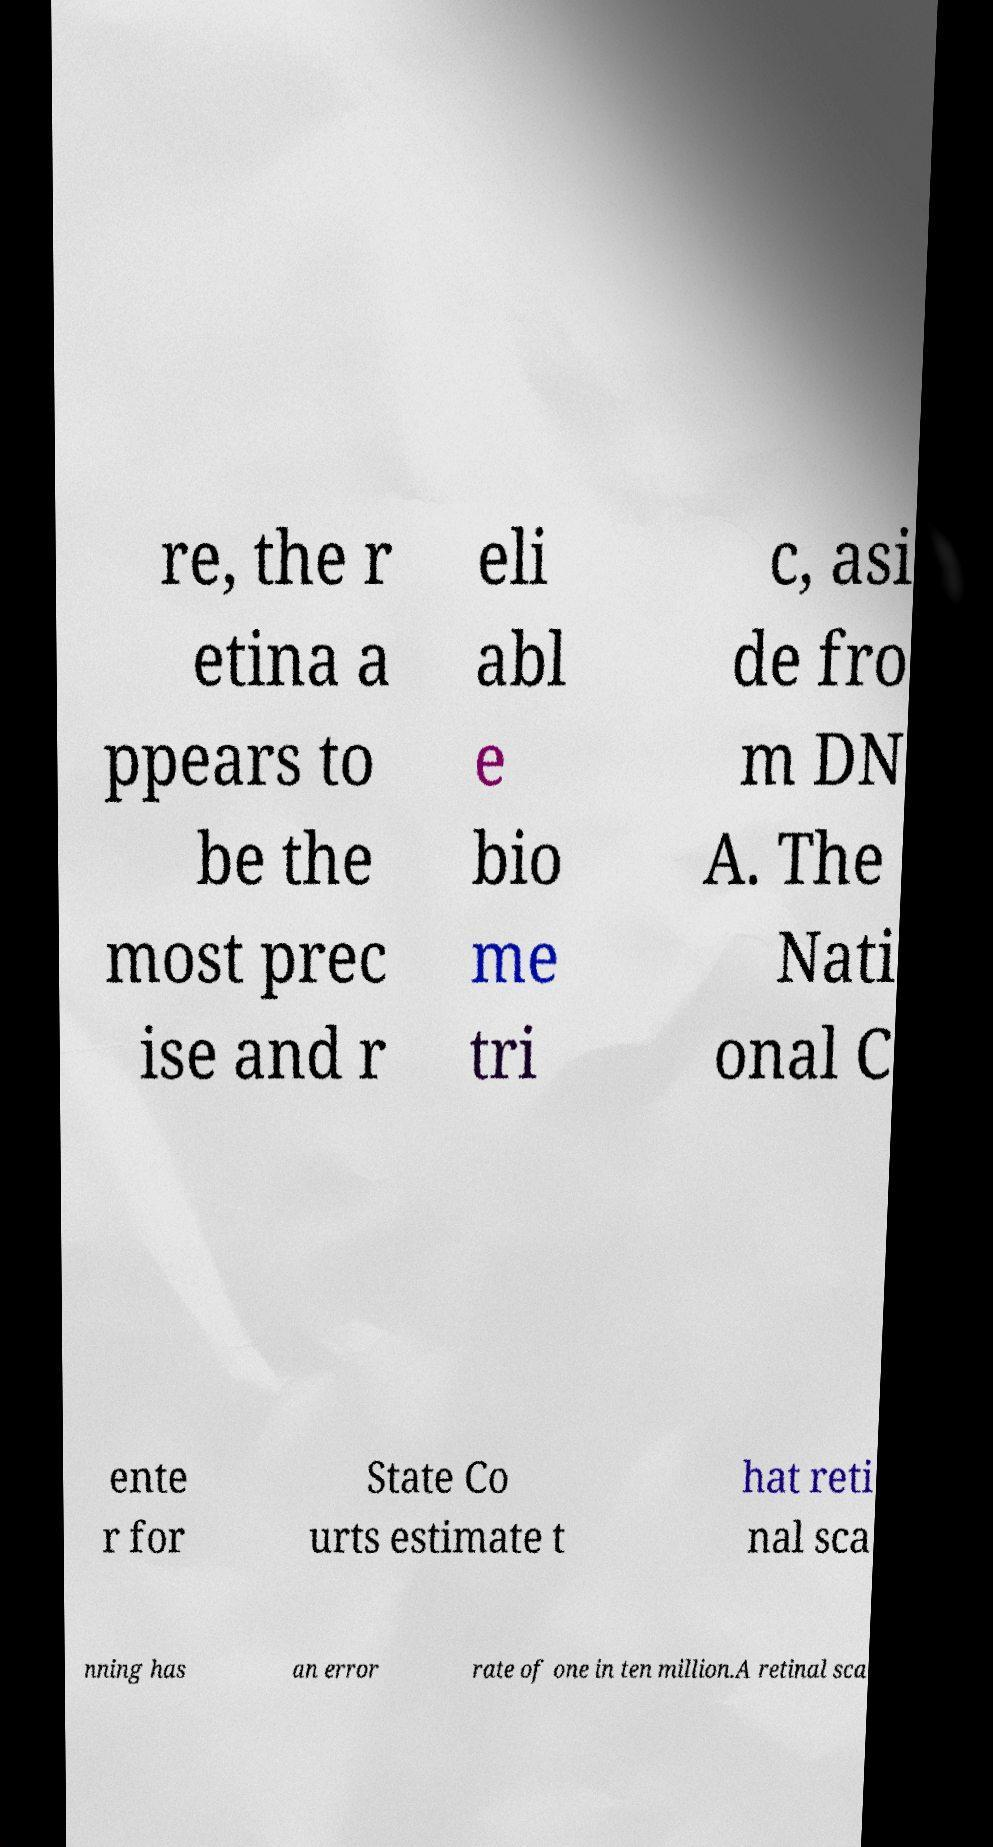I need the written content from this picture converted into text. Can you do that? re, the r etina a ppears to be the most prec ise and r eli abl e bio me tri c, asi de fro m DN A. The Nati onal C ente r for State Co urts estimate t hat reti nal sca nning has an error rate of one in ten million.A retinal sca 